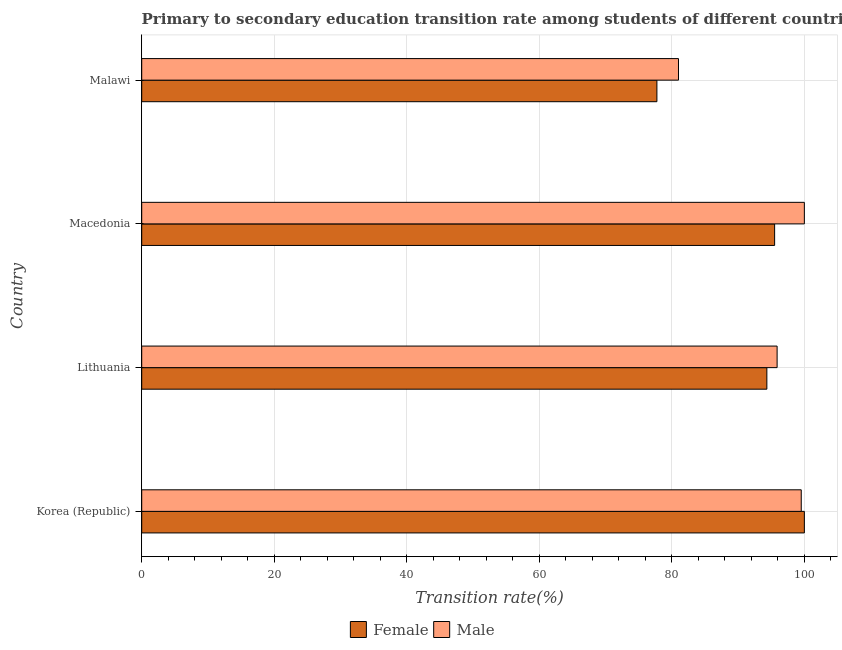How many groups of bars are there?
Make the answer very short. 4. Are the number of bars per tick equal to the number of legend labels?
Ensure brevity in your answer.  Yes. Are the number of bars on each tick of the Y-axis equal?
Give a very brief answer. Yes. How many bars are there on the 1st tick from the top?
Your response must be concise. 2. How many bars are there on the 1st tick from the bottom?
Make the answer very short. 2. What is the label of the 1st group of bars from the top?
Offer a very short reply. Malawi. In how many cases, is the number of bars for a given country not equal to the number of legend labels?
Offer a terse response. 0. What is the transition rate among female students in Macedonia?
Ensure brevity in your answer.  95.51. Across all countries, what is the minimum transition rate among male students?
Provide a succinct answer. 81. In which country was the transition rate among male students maximum?
Ensure brevity in your answer.  Macedonia. In which country was the transition rate among male students minimum?
Your answer should be very brief. Malawi. What is the total transition rate among male students in the graph?
Ensure brevity in your answer.  376.42. What is the difference between the transition rate among male students in Macedonia and that in Malawi?
Your response must be concise. 19. What is the difference between the transition rate among male students in Korea (Republic) and the transition rate among female students in Macedonia?
Provide a short and direct response. 4.02. What is the average transition rate among female students per country?
Make the answer very short. 91.9. What is the difference between the transition rate among male students and transition rate among female students in Lithuania?
Provide a succinct answer. 1.55. In how many countries, is the transition rate among female students greater than 52 %?
Make the answer very short. 4. What is the ratio of the transition rate among male students in Korea (Republic) to that in Malawi?
Your response must be concise. 1.23. Is the transition rate among male students in Lithuania less than that in Macedonia?
Make the answer very short. Yes. What is the difference between the highest and the second highest transition rate among female students?
Offer a very short reply. 4.49. In how many countries, is the transition rate among male students greater than the average transition rate among male students taken over all countries?
Provide a succinct answer. 3. What does the 2nd bar from the top in Korea (Republic) represents?
Make the answer very short. Female. How many bars are there?
Keep it short and to the point. 8. Are all the bars in the graph horizontal?
Provide a short and direct response. Yes. What is the difference between two consecutive major ticks on the X-axis?
Give a very brief answer. 20. Does the graph contain any zero values?
Offer a terse response. No. Does the graph contain grids?
Offer a terse response. Yes. Where does the legend appear in the graph?
Keep it short and to the point. Bottom center. How are the legend labels stacked?
Your answer should be compact. Horizontal. What is the title of the graph?
Offer a very short reply. Primary to secondary education transition rate among students of different countries. What is the label or title of the X-axis?
Ensure brevity in your answer.  Transition rate(%). What is the Transition rate(%) in Male in Korea (Republic)?
Your response must be concise. 99.53. What is the Transition rate(%) in Female in Lithuania?
Your answer should be compact. 94.34. What is the Transition rate(%) of Male in Lithuania?
Your answer should be very brief. 95.89. What is the Transition rate(%) in Female in Macedonia?
Provide a short and direct response. 95.51. What is the Transition rate(%) of Male in Macedonia?
Make the answer very short. 100. What is the Transition rate(%) in Female in Malawi?
Keep it short and to the point. 77.75. What is the Transition rate(%) of Male in Malawi?
Provide a succinct answer. 81. Across all countries, what is the maximum Transition rate(%) in Female?
Offer a terse response. 100. Across all countries, what is the maximum Transition rate(%) of Male?
Ensure brevity in your answer.  100. Across all countries, what is the minimum Transition rate(%) in Female?
Your answer should be compact. 77.75. Across all countries, what is the minimum Transition rate(%) of Male?
Keep it short and to the point. 81. What is the total Transition rate(%) of Female in the graph?
Your response must be concise. 367.6. What is the total Transition rate(%) in Male in the graph?
Provide a short and direct response. 376.42. What is the difference between the Transition rate(%) in Female in Korea (Republic) and that in Lithuania?
Offer a very short reply. 5.66. What is the difference between the Transition rate(%) in Male in Korea (Republic) and that in Lithuania?
Make the answer very short. 3.64. What is the difference between the Transition rate(%) in Female in Korea (Republic) and that in Macedonia?
Your answer should be compact. 4.49. What is the difference between the Transition rate(%) of Male in Korea (Republic) and that in Macedonia?
Provide a short and direct response. -0.47. What is the difference between the Transition rate(%) in Female in Korea (Republic) and that in Malawi?
Keep it short and to the point. 22.25. What is the difference between the Transition rate(%) of Male in Korea (Republic) and that in Malawi?
Offer a terse response. 18.53. What is the difference between the Transition rate(%) in Female in Lithuania and that in Macedonia?
Your answer should be compact. -1.17. What is the difference between the Transition rate(%) of Male in Lithuania and that in Macedonia?
Offer a terse response. -4.11. What is the difference between the Transition rate(%) of Female in Lithuania and that in Malawi?
Ensure brevity in your answer.  16.59. What is the difference between the Transition rate(%) in Male in Lithuania and that in Malawi?
Provide a succinct answer. 14.88. What is the difference between the Transition rate(%) of Female in Macedonia and that in Malawi?
Give a very brief answer. 17.77. What is the difference between the Transition rate(%) in Male in Macedonia and that in Malawi?
Give a very brief answer. 19. What is the difference between the Transition rate(%) in Female in Korea (Republic) and the Transition rate(%) in Male in Lithuania?
Your answer should be compact. 4.11. What is the difference between the Transition rate(%) in Female in Korea (Republic) and the Transition rate(%) in Male in Macedonia?
Your answer should be very brief. 0. What is the difference between the Transition rate(%) in Female in Korea (Republic) and the Transition rate(%) in Male in Malawi?
Give a very brief answer. 19. What is the difference between the Transition rate(%) in Female in Lithuania and the Transition rate(%) in Male in Macedonia?
Offer a very short reply. -5.66. What is the difference between the Transition rate(%) in Female in Lithuania and the Transition rate(%) in Male in Malawi?
Give a very brief answer. 13.34. What is the difference between the Transition rate(%) of Female in Macedonia and the Transition rate(%) of Male in Malawi?
Provide a succinct answer. 14.51. What is the average Transition rate(%) in Female per country?
Give a very brief answer. 91.9. What is the average Transition rate(%) of Male per country?
Your response must be concise. 94.11. What is the difference between the Transition rate(%) of Female and Transition rate(%) of Male in Korea (Republic)?
Your answer should be compact. 0.47. What is the difference between the Transition rate(%) in Female and Transition rate(%) in Male in Lithuania?
Offer a very short reply. -1.55. What is the difference between the Transition rate(%) of Female and Transition rate(%) of Male in Macedonia?
Offer a very short reply. -4.49. What is the difference between the Transition rate(%) in Female and Transition rate(%) in Male in Malawi?
Provide a short and direct response. -3.26. What is the ratio of the Transition rate(%) of Female in Korea (Republic) to that in Lithuania?
Offer a terse response. 1.06. What is the ratio of the Transition rate(%) of Male in Korea (Republic) to that in Lithuania?
Your response must be concise. 1.04. What is the ratio of the Transition rate(%) in Female in Korea (Republic) to that in Macedonia?
Offer a very short reply. 1.05. What is the ratio of the Transition rate(%) in Male in Korea (Republic) to that in Macedonia?
Ensure brevity in your answer.  1. What is the ratio of the Transition rate(%) of Female in Korea (Republic) to that in Malawi?
Make the answer very short. 1.29. What is the ratio of the Transition rate(%) of Male in Korea (Republic) to that in Malawi?
Make the answer very short. 1.23. What is the ratio of the Transition rate(%) of Male in Lithuania to that in Macedonia?
Offer a terse response. 0.96. What is the ratio of the Transition rate(%) in Female in Lithuania to that in Malawi?
Give a very brief answer. 1.21. What is the ratio of the Transition rate(%) of Male in Lithuania to that in Malawi?
Your answer should be very brief. 1.18. What is the ratio of the Transition rate(%) of Female in Macedonia to that in Malawi?
Your response must be concise. 1.23. What is the ratio of the Transition rate(%) in Male in Macedonia to that in Malawi?
Provide a short and direct response. 1.23. What is the difference between the highest and the second highest Transition rate(%) of Female?
Provide a short and direct response. 4.49. What is the difference between the highest and the second highest Transition rate(%) of Male?
Your response must be concise. 0.47. What is the difference between the highest and the lowest Transition rate(%) in Female?
Keep it short and to the point. 22.25. What is the difference between the highest and the lowest Transition rate(%) of Male?
Give a very brief answer. 19. 